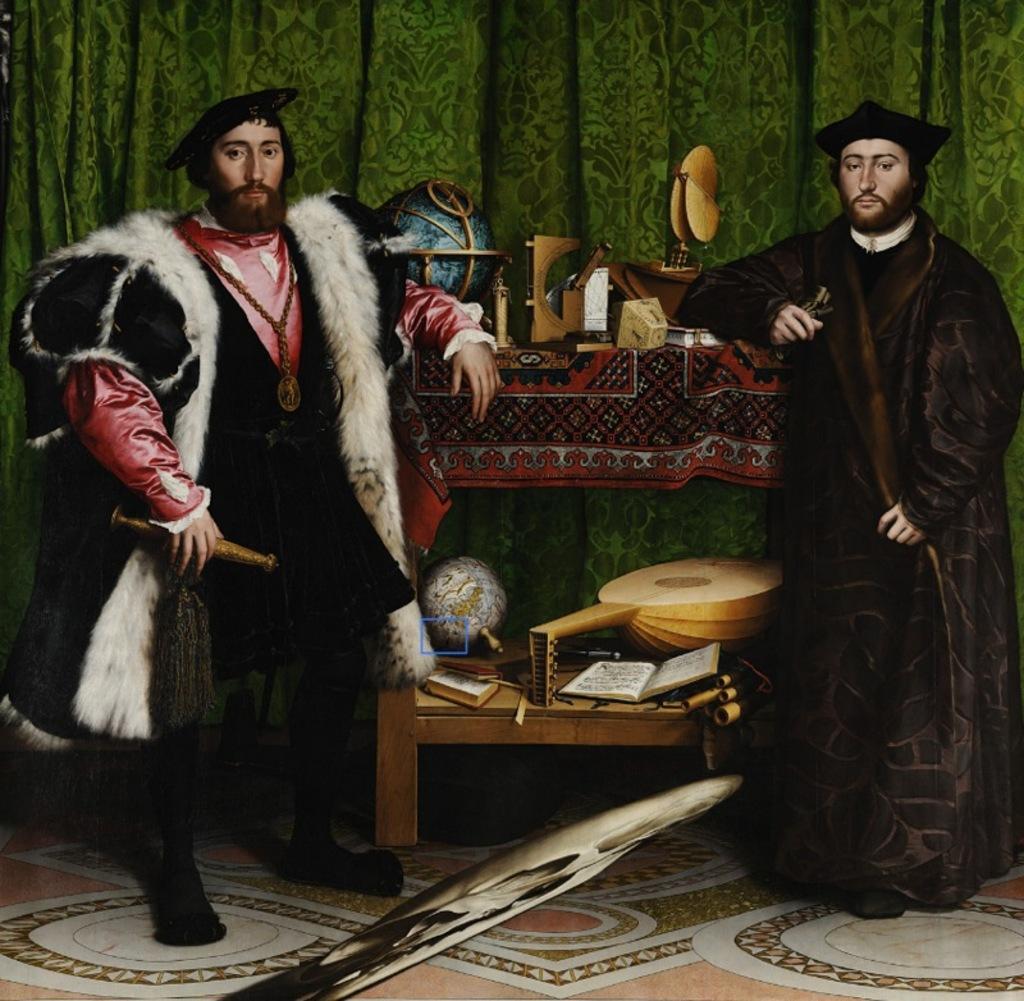In one or two sentences, can you explain what this image depicts? In the picture I can see two persons standing and placed their hands on a table which is in between them and there are few objects placed on the table and there are green color curtains in the background. 